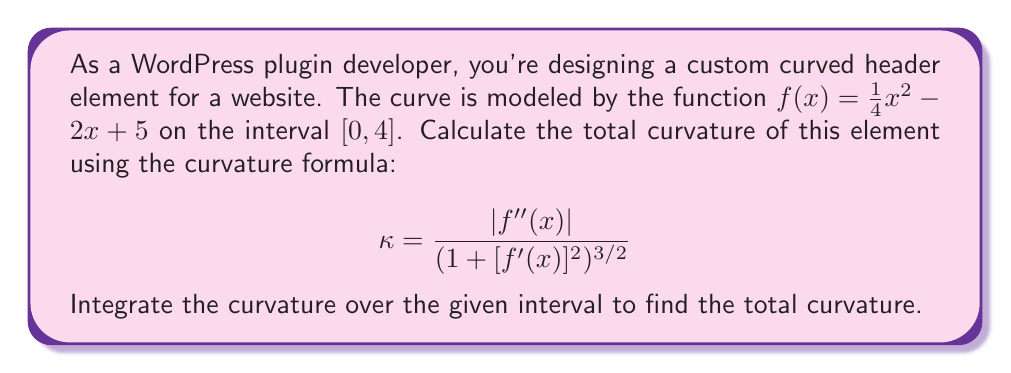Solve this math problem. Let's approach this step-by-step:

1) First, we need to find $f'(x)$ and $f''(x)$:
   $f'(x) = \frac{1}{2}x - 2$
   $f''(x) = \frac{1}{2}$

2) Now, let's substitute these into the curvature formula:
   $$\kappa = \frac{|\frac{1}{2}|}{(1 + [\frac{1}{2}x - 2]^2)^{3/2}}$$

3) Simplify the absolute value in the numerator:
   $$\kappa = \frac{\frac{1}{2}}{(1 + [\frac{1}{2}x - 2]^2)^{3/2}}$$

4) To find the total curvature, we need to integrate this over the interval $[0, 4]$:
   $$\text{Total Curvature} = \int_0^4 \frac{\frac{1}{2}}{(1 + [\frac{1}{2}x - 2]^2)^{3/2}} dx$$

5) This integral is complex and doesn't have an elementary antiderivative. We can solve it using the substitution $u = \frac{1}{2}x - 2$:

   $$\int_0^4 \frac{\frac{1}{2}}{(1 + [\frac{1}{2}x - 2]^2)^{3/2}} dx = \int_{-2}^0 \frac{1}{(1 + u^2)^{3/2}} du$$

6) This is a standard integral form. The antiderivative is:
   $$\frac{u}{\sqrt{1+u^2}} + C$$

7) Evaluating at the limits:
   $$\left[\frac{u}{\sqrt{1+u^2}}\right]_{-2}^0 = 0 - \frac{-2}{\sqrt{1+4}} = \frac{2}{\sqrt{5}}$$

Thus, the total curvature of the header element is $\frac{2}{\sqrt{5}}$.
Answer: $\frac{2}{\sqrt{5}}$ 